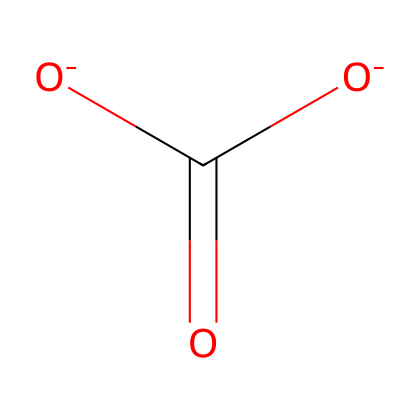What is the name of this chemical? The SMILES representation shows the ionic structure consisting of carbon, oxygen, and hydrogen, which corresponds to bicarbonate, commonly known as baking soda.
Answer: bicarbonate How many oxygen atoms are present? In the structure, there are a total of three oxygen atoms directly attached to the carbon atom, which can be counted from the SMILES representation.
Answer: three What charge does the bicarbonate ion carry? Bicarbonate contains two negatively charged oxygen atoms, indicating an overall charge of minus one (it’s a weak electrolyte).
Answer: minus one What type of chemical is bicarbonate? Bicarbonate (HCO₃⁻) is classified as an electrolyte because it dissociates into ions in solution, allowing it to conduct electricity.
Answer: electrolyte Which functional groups are present in this chemical? The presence of a carboxylate group (-COO) as part of the structure indicates that bicarbonate has carboxylic acid functional characteristics.
Answer: carboxylate What is the role of bicarbonate in baking? In baking, bicarbonate acts as a leavening agent. When combined with an acid, it releases carbon dioxide gas, causing dough or batter to rise.
Answer: leavening agent 